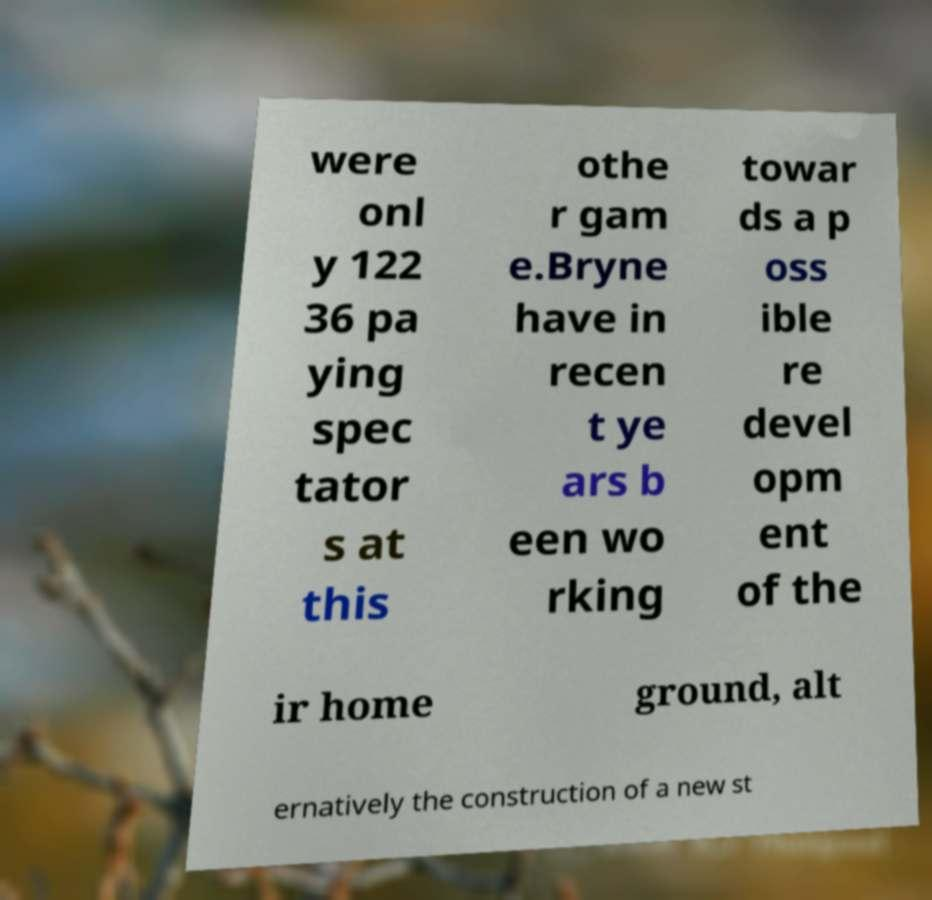Please identify and transcribe the text found in this image. were onl y 122 36 pa ying spec tator s at this othe r gam e.Bryne have in recen t ye ars b een wo rking towar ds a p oss ible re devel opm ent of the ir home ground, alt ernatively the construction of a new st 